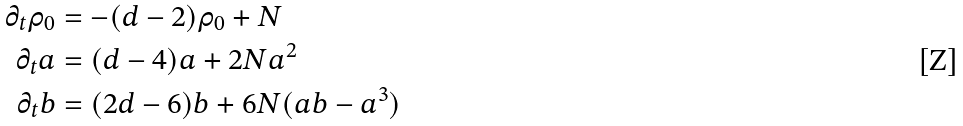Convert formula to latex. <formula><loc_0><loc_0><loc_500><loc_500>\partial _ { t } \rho _ { 0 } & = - ( d - 2 ) \rho _ { 0 } + N \\ \partial _ { t } a & = ( d - 4 ) a + 2 N a ^ { 2 } \\ \partial _ { t } b & = ( 2 d - 6 ) b + 6 N ( a b - a ^ { 3 } )</formula> 